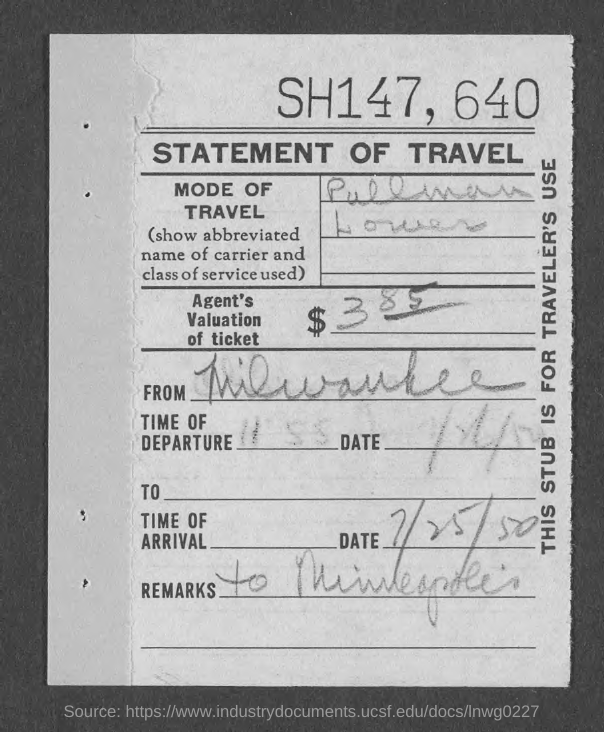What is the Title of the document?
Your answer should be very brief. Statement of Travel. What is the mode of travel?
Provide a short and direct response. Pullman Lower. What is the Agent's valuation of ticket?
Your answer should be compact. $ 385. Where is it From?
Give a very brief answer. Milwaukee. What is the date of arrival?
Offer a very short reply. 7/25/50. What are the remarks?
Offer a terse response. To minneapolis. 